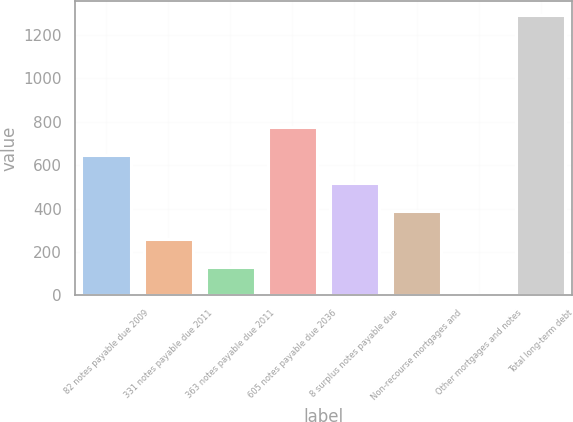Convert chart. <chart><loc_0><loc_0><loc_500><loc_500><bar_chart><fcel>82 notes payable due 2009<fcel>331 notes payable due 2011<fcel>363 notes payable due 2011<fcel>605 notes payable due 2036<fcel>8 surplus notes payable due<fcel>Non-recourse mortgages and<fcel>Other mortgages and notes<fcel>Total long-term debt<nl><fcel>645.45<fcel>258.42<fcel>129.41<fcel>774.46<fcel>516.44<fcel>387.43<fcel>0.4<fcel>1290.5<nl></chart> 